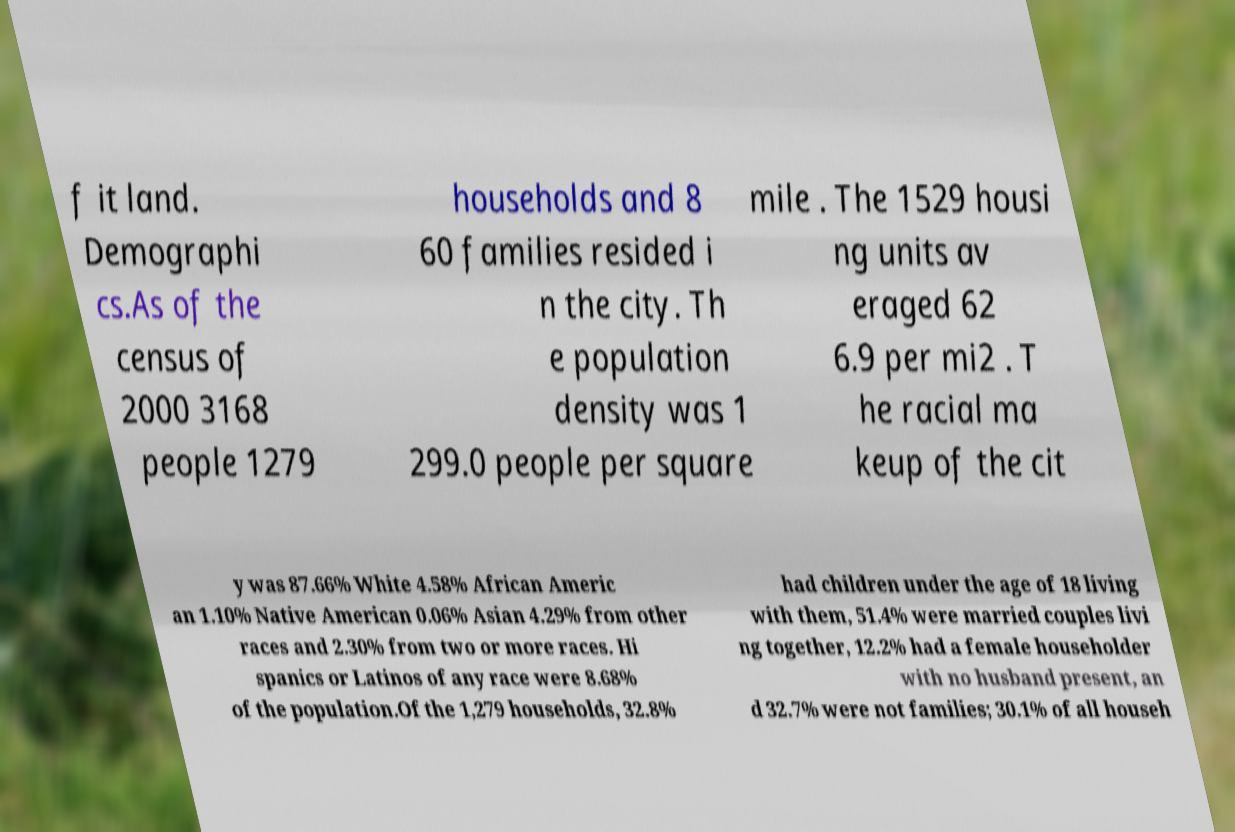Please read and relay the text visible in this image. What does it say? f it land. Demographi cs.As of the census of 2000 3168 people 1279 households and 8 60 families resided i n the city. Th e population density was 1 299.0 people per square mile . The 1529 housi ng units av eraged 62 6.9 per mi2 . T he racial ma keup of the cit y was 87.66% White 4.58% African Americ an 1.10% Native American 0.06% Asian 4.29% from other races and 2.30% from two or more races. Hi spanics or Latinos of any race were 8.68% of the population.Of the 1,279 households, 32.8% had children under the age of 18 living with them, 51.4% were married couples livi ng together, 12.2% had a female householder with no husband present, an d 32.7% were not families; 30.1% of all househ 